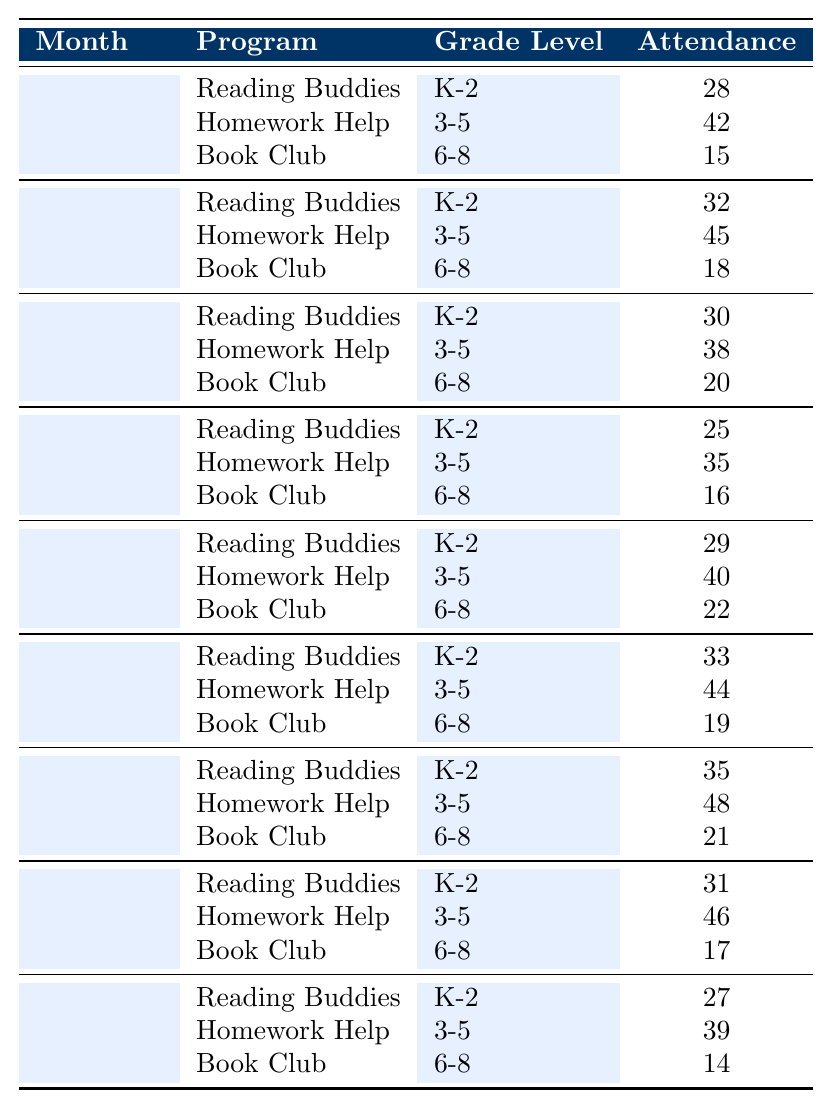What is the total attendance for Homework Help in March? The attendance for Homework Help in March is 48 based on the table.
Answer: 48 Which program had the highest attendance in February? In February, Homework Help had the highest attendance with 44.
Answer: Homework Help What is the average attendance for Book Club across all months? The total attendance for Book Club is (15 + 18 + 20 + 16 + 22 + 19 + 21 + 17 + 14) = 162, and there are 9 observations, so the average is 162/9 = 18.
Answer: 18 Did the attendance for Reading Buddies increase in October compared to September? The attendance in September was 28 and in October was 32; since 32 > 28, attendance increased.
Answer: Yes In which month did Homework Help show the greatest attendance? Looking through the attendance values, Homework Help had its highest attendance in March with 48.
Answer: March What is the total attendance for K-2 grade level across all months? The total attendance for K-2 is (28 + 32 + 30 + 25 + 29 + 33 + 35 + 31 + 27) =  270.
Answer: 270 Was the attendance for Book Club in November higher than in December? Attendance for Book Club was 20 in November and 16 in December, which means November had higher attendance.
Answer: Yes What was the difference in attendance for Homework Help between November and January? Homework Help had 38 in November and 40 in January; the difference is 40 - 38 = 2.
Answer: 2 Which grade level had the lowest overall attendance across all programs? Comparing total attendances, Book Club (162) had the lowest, while K-2 and Homework Help had higher totals.
Answer: Book Club What was the total attendance for all after-school library programs in April? The total attendance in April was (31 + 46 + 17) = 94 across all programs.
Answer: 94 Which program had consistently increasing attendance from September to March? Reading Buddies attendance in September (28), October (32), November (30), December (25), January (29), February (33), March (35) shows an overall increasing trend except December.
Answer: No, it didn't have consistent increase 